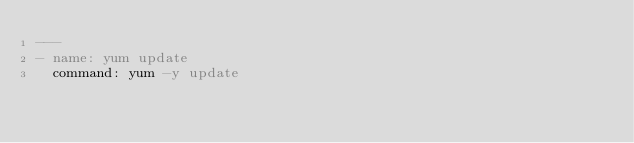Convert code to text. <code><loc_0><loc_0><loc_500><loc_500><_YAML_>---
- name: yum update
  command: yum -y update
</code> 